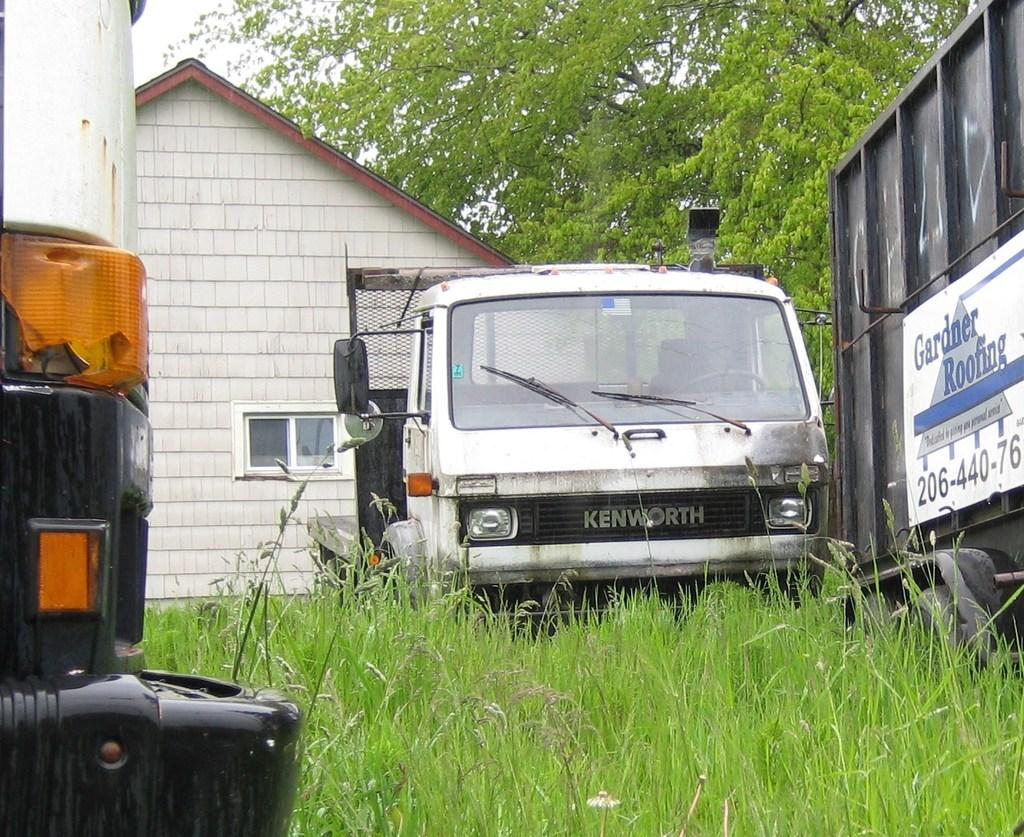<image>
Write a terse but informative summary of the picture. the front of a vehicle that is labeled 'kenworth' on it 